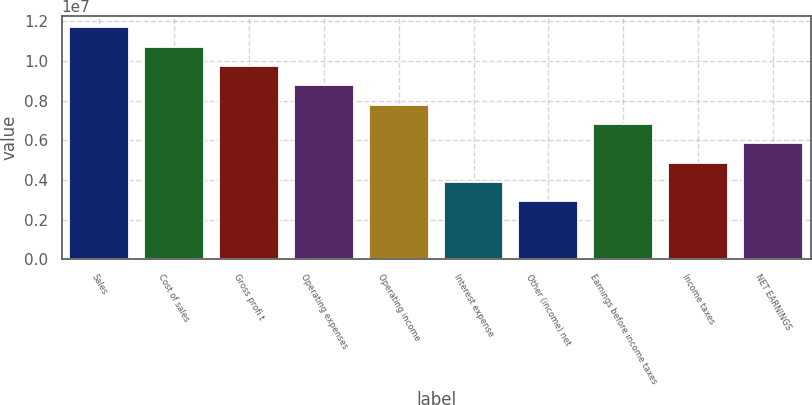<chart> <loc_0><loc_0><loc_500><loc_500><bar_chart><fcel>Sales<fcel>Cost of sales<fcel>Gross profi t<fcel>Operating expenses<fcel>Operating income<fcel>Interest expense<fcel>Other (income) net<fcel>Earnings before income taxes<fcel>Income taxes<fcel>NET EARNINGS<nl><fcel>1.17015e+07<fcel>1.07264e+07<fcel>9.75127e+06<fcel>8.77615e+06<fcel>7.80102e+06<fcel>3.90051e+06<fcel>2.92538e+06<fcel>6.82589e+06<fcel>4.87564e+06<fcel>5.85076e+06<nl></chart> 